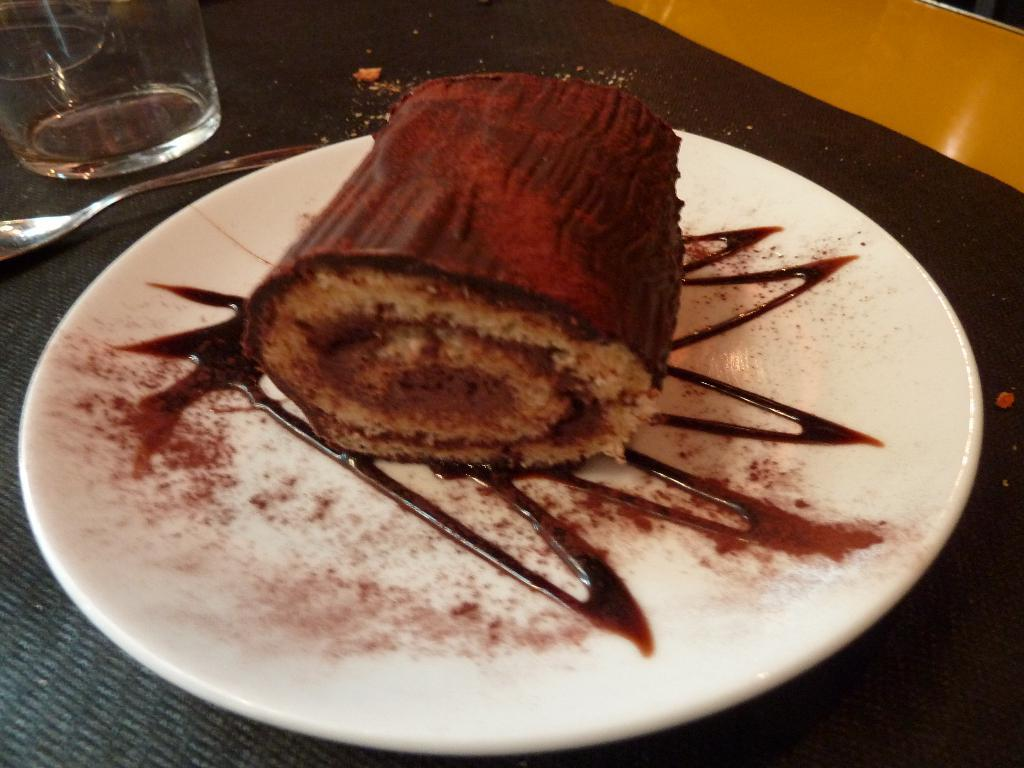What is on the plate that is visible in the image? There is a plate with food in the image. What else can be seen in the image besides the plate with food? There is a glass and a spoon visible in the image. Where are the plate, glass, and spoon placed in the image? The plate, glass, and spoon are placed on a platform. How many frogs are sitting on the tramp in the image? There are no frogs or tramps present in the image. 